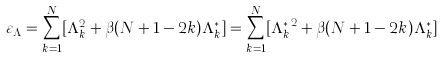Convert formula to latex. <formula><loc_0><loc_0><loc_500><loc_500>\varepsilon _ { \Lambda } = \sum _ { k = 1 } ^ { N } [ \Lambda _ { k } ^ { 2 } + \beta ( N + 1 - 2 k ) \Lambda _ { k } ^ { * } ] = \sum _ { k = 1 } ^ { N } [ { \Lambda _ { k } ^ { * } } ^ { 2 } + \beta ( N + 1 - 2 k ) \Lambda _ { k } ^ { * } ]</formula> 